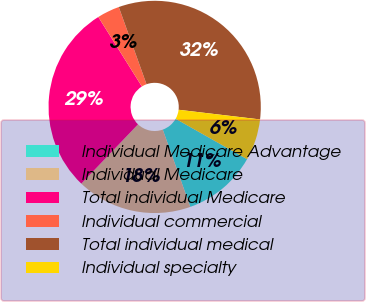Convert chart. <chart><loc_0><loc_0><loc_500><loc_500><pie_chart><fcel>Individual Medicare Advantage<fcel>Individual Medicare<fcel>Total individual Medicare<fcel>Individual commercial<fcel>Total individual medical<fcel>Individual specialty<nl><fcel>11.36%<fcel>17.59%<fcel>28.95%<fcel>3.42%<fcel>32.37%<fcel>6.31%<nl></chart> 